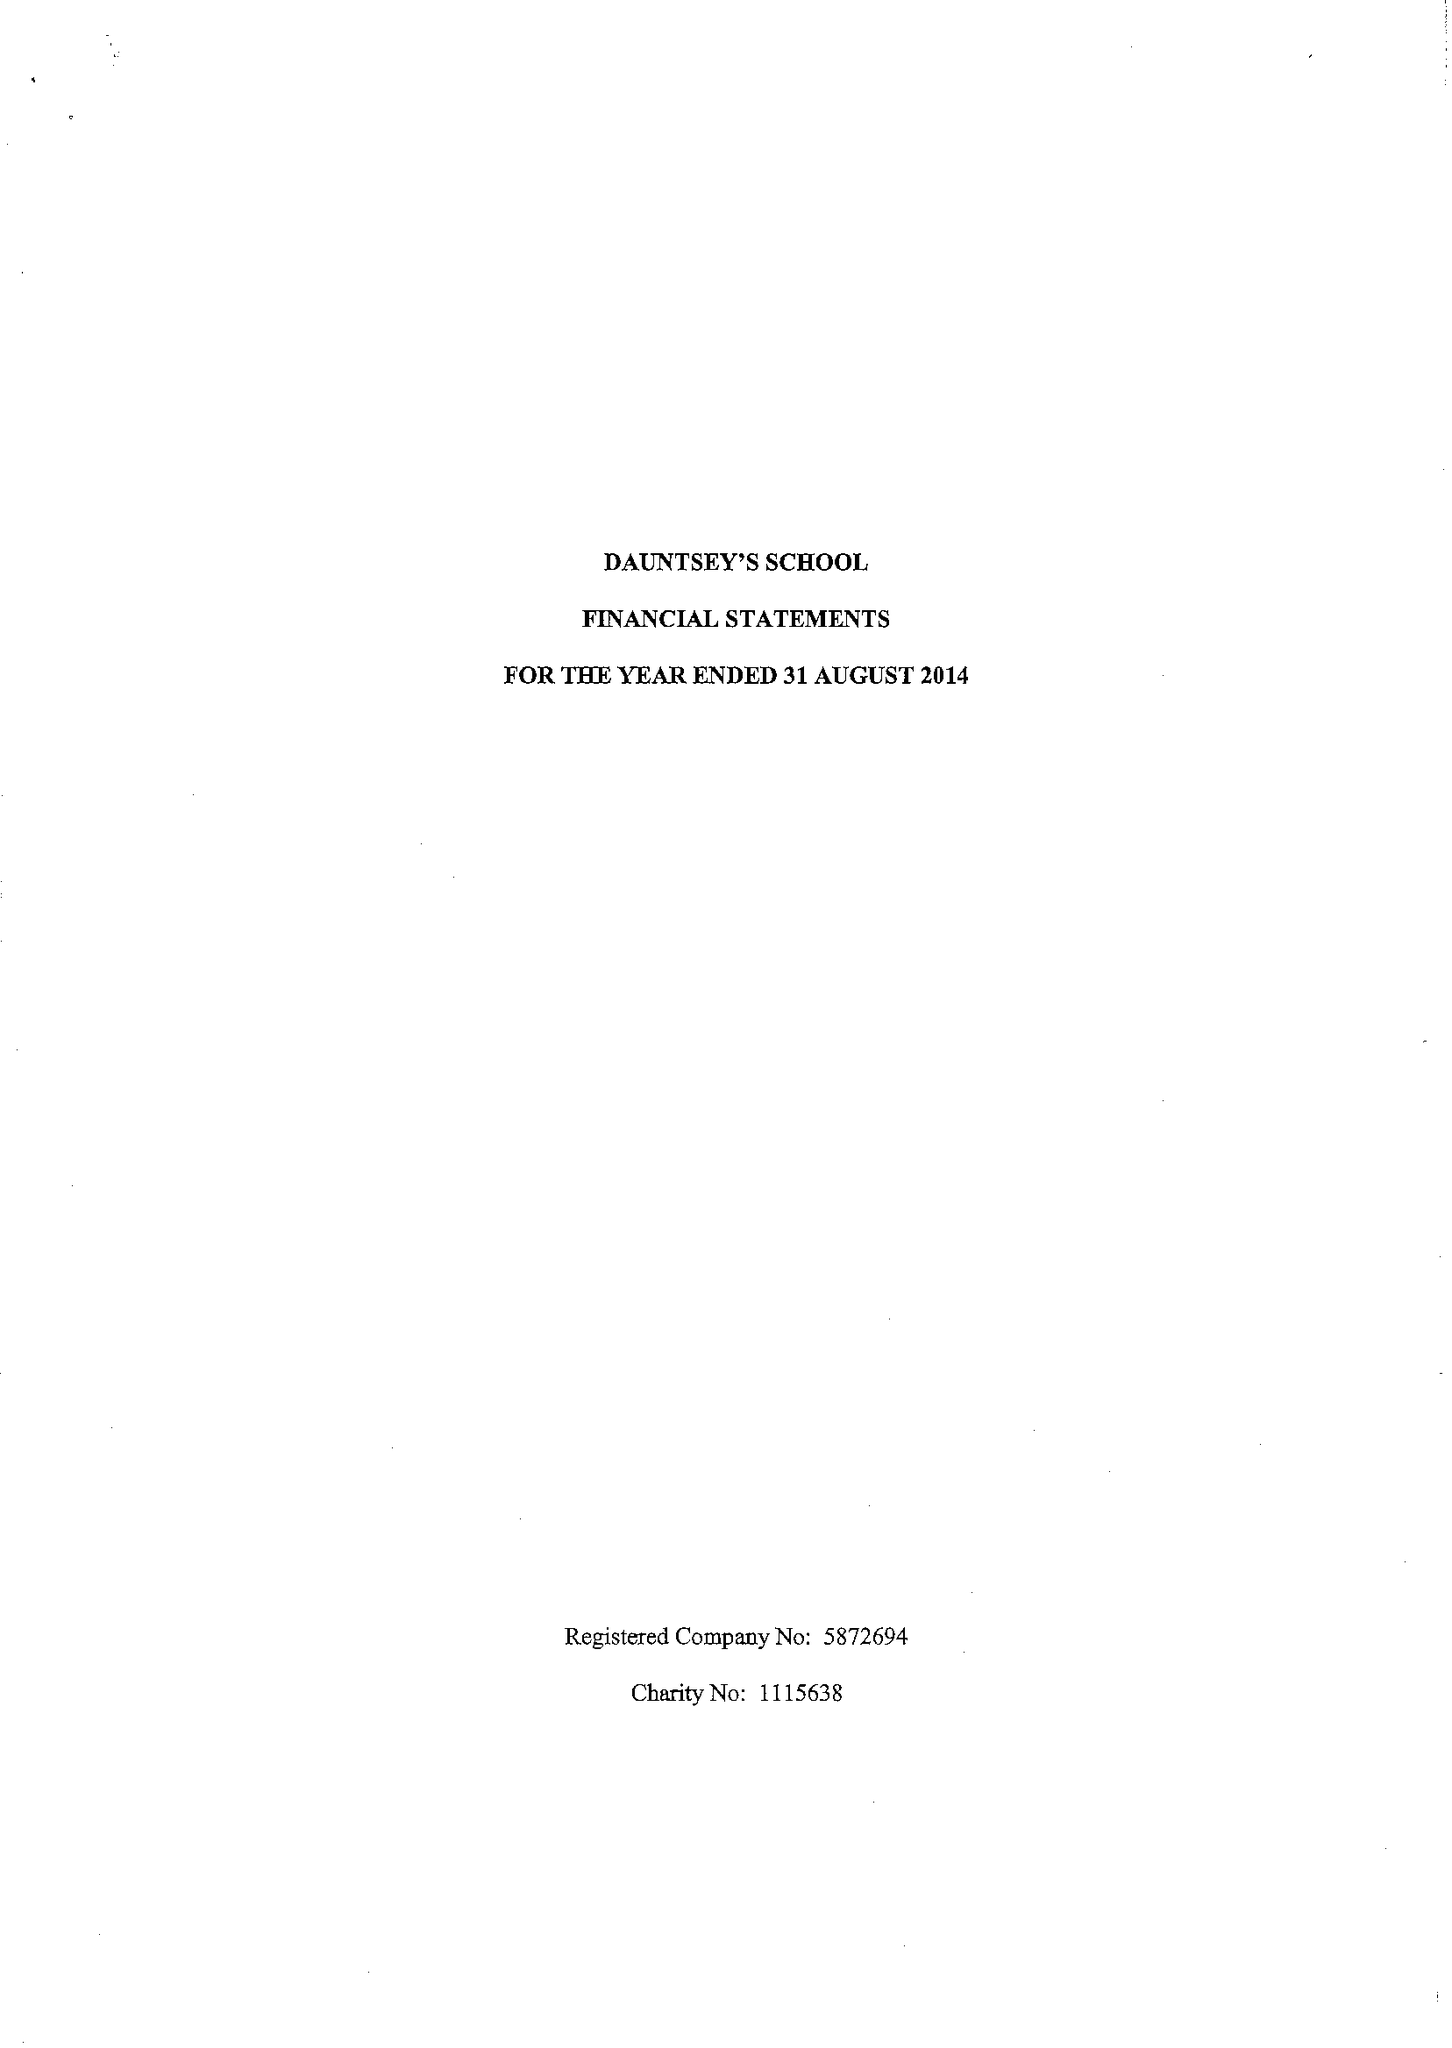What is the value for the income_annually_in_british_pounds?
Answer the question using a single word or phrase. 16301854.00 